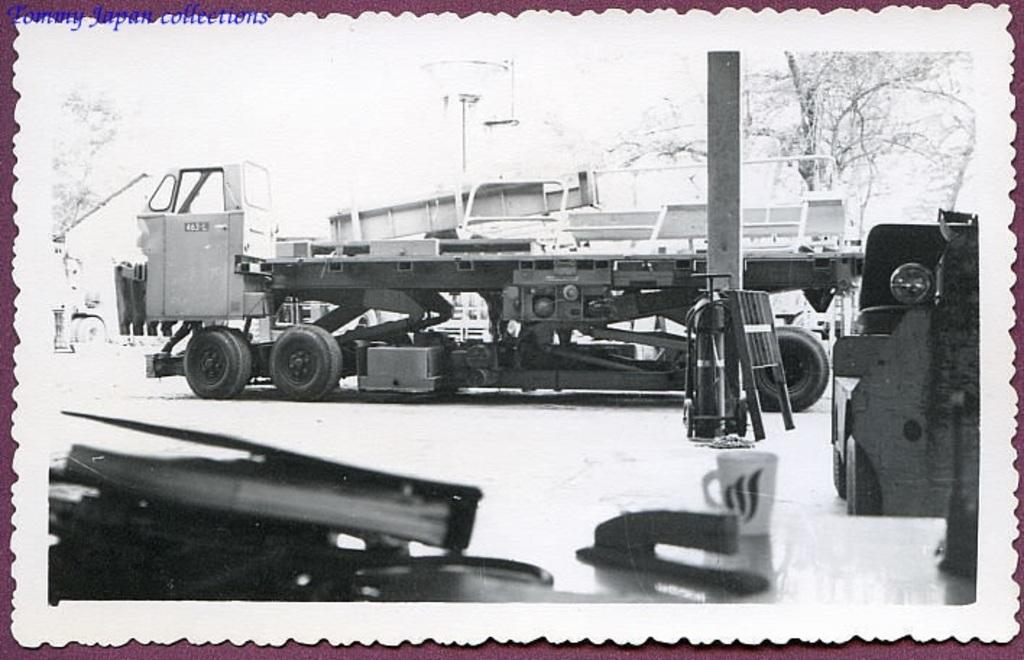What is the main subject of the image? The image contains a photo. What type of vehicle is in the photo? There is a vehicle in the photo. What type of structure is in the photo? There is a building in the photo. What type of natural element is visible in the photo? There is a tree visible in the photo. What other objects can be seen in the photo? There are other objects visible in the photo. What type of wilderness can be seen in the photo? There is no wilderness present in the photo; it contains a vehicle, building, tree, and other objects. How many arms are visible in the photo? There are no arms visible in the photo, as it contains a vehicle, building, tree, and other objects. 